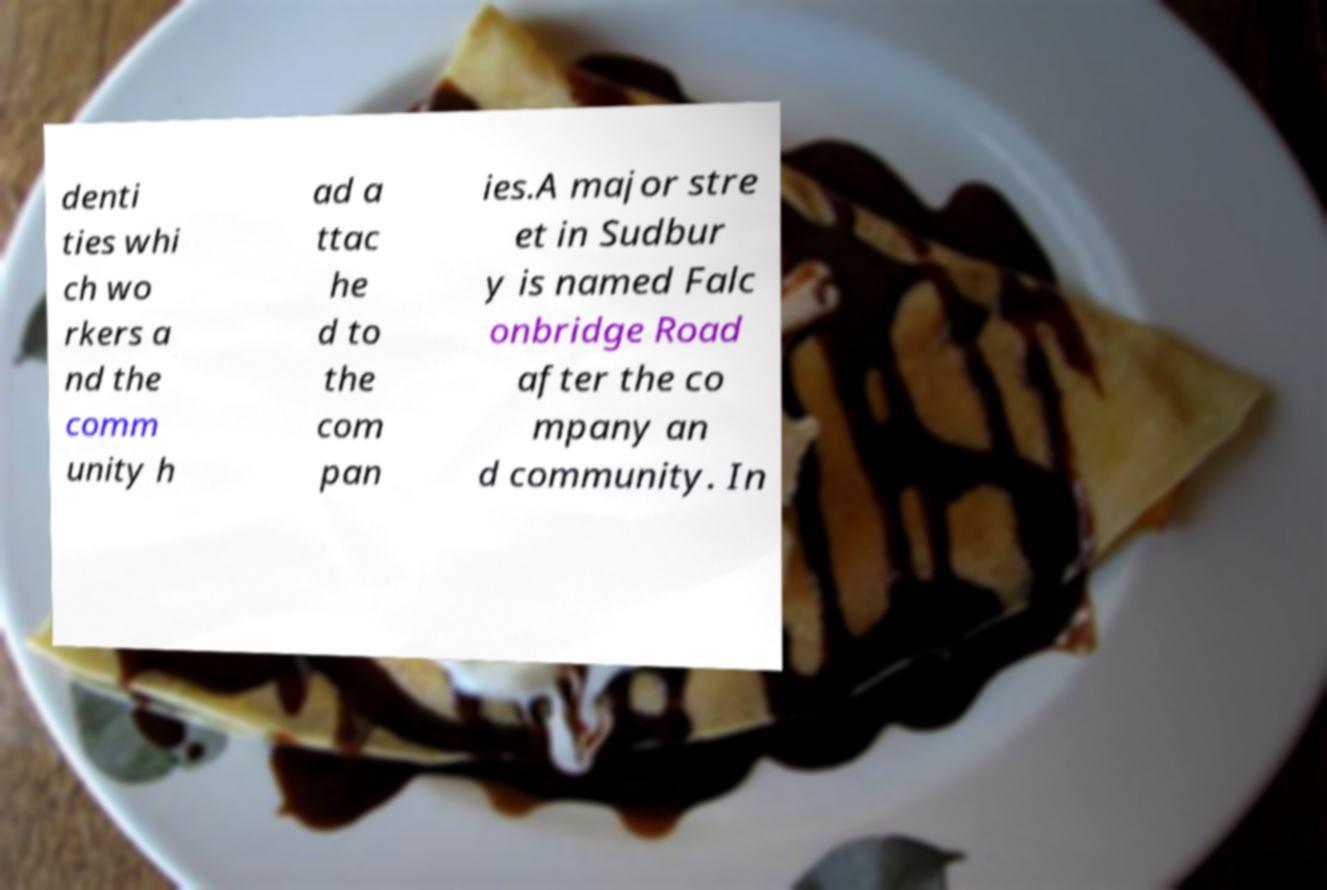Could you assist in decoding the text presented in this image and type it out clearly? denti ties whi ch wo rkers a nd the comm unity h ad a ttac he d to the com pan ies.A major stre et in Sudbur y is named Falc onbridge Road after the co mpany an d community. In 